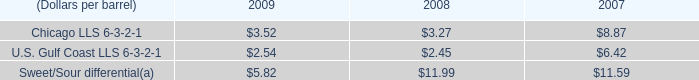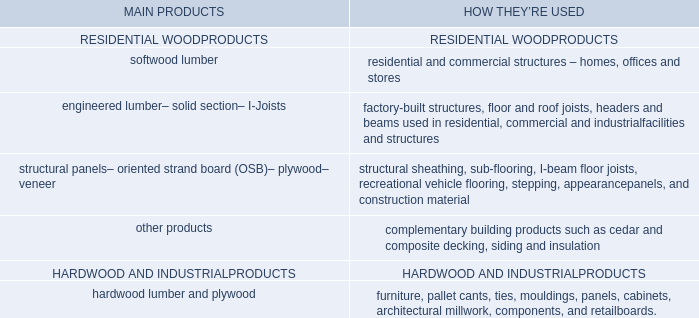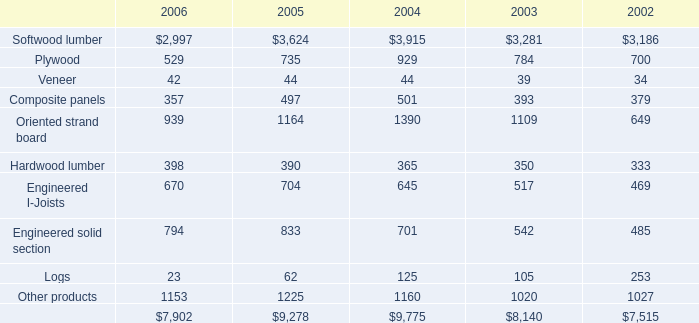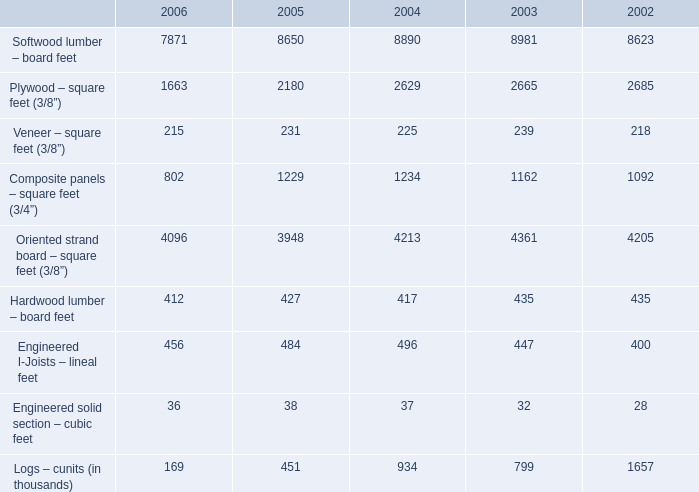When does Softwood lumber – board feet reach the largest value? 
Answer: 2003. 